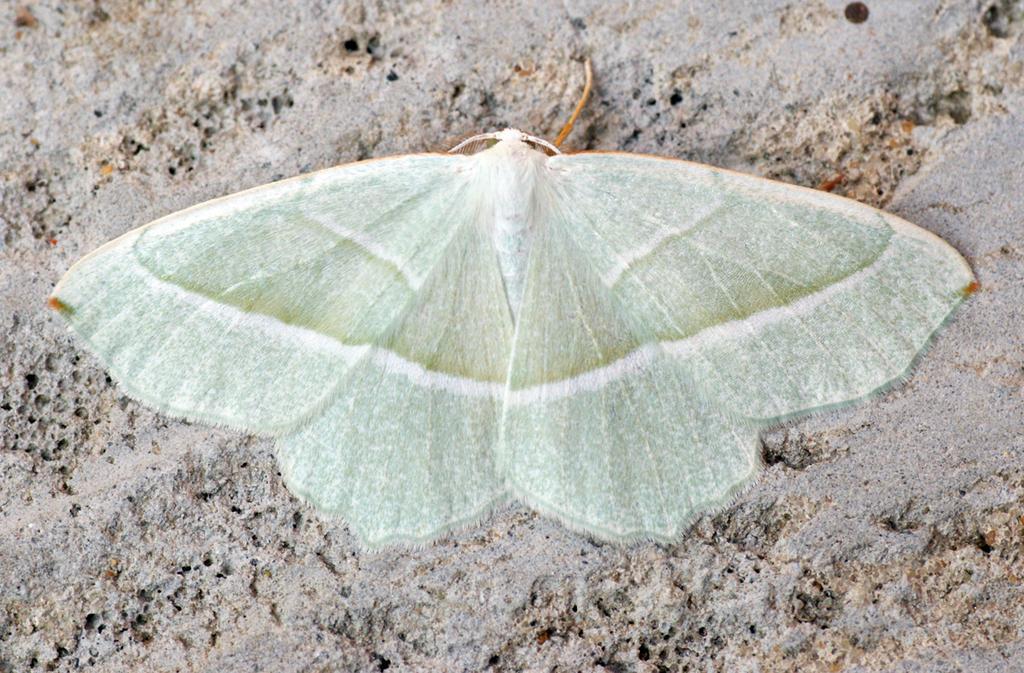Could you give a brief overview of what you see in this image? In this image, we can see a butterfly which is on the sand. 